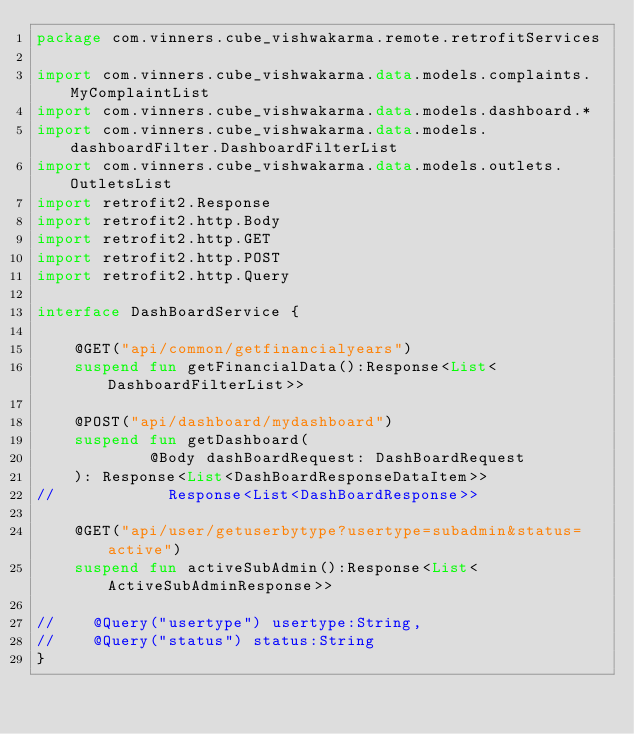<code> <loc_0><loc_0><loc_500><loc_500><_Kotlin_>package com.vinners.cube_vishwakarma.remote.retrofitServices

import com.vinners.cube_vishwakarma.data.models.complaints.MyComplaintList
import com.vinners.cube_vishwakarma.data.models.dashboard.*
import com.vinners.cube_vishwakarma.data.models.dashboardFilter.DashboardFilterList
import com.vinners.cube_vishwakarma.data.models.outlets.OutletsList
import retrofit2.Response
import retrofit2.http.Body
import retrofit2.http.GET
import retrofit2.http.POST
import retrofit2.http.Query

interface DashBoardService {

    @GET("api/common/getfinancialyears")
    suspend fun getFinancialData():Response<List<DashboardFilterList>>

    @POST("api/dashboard/mydashboard")
    suspend fun getDashboard(
            @Body dashBoardRequest: DashBoardRequest
    ): Response<List<DashBoardResponseDataItem>>
//            Response<List<DashBoardResponse>>

    @GET("api/user/getuserbytype?usertype=subadmin&status=active")
    suspend fun activeSubAdmin():Response<List<ActiveSubAdminResponse>>

//    @Query("usertype") usertype:String,
//    @Query("status") status:String
}</code> 